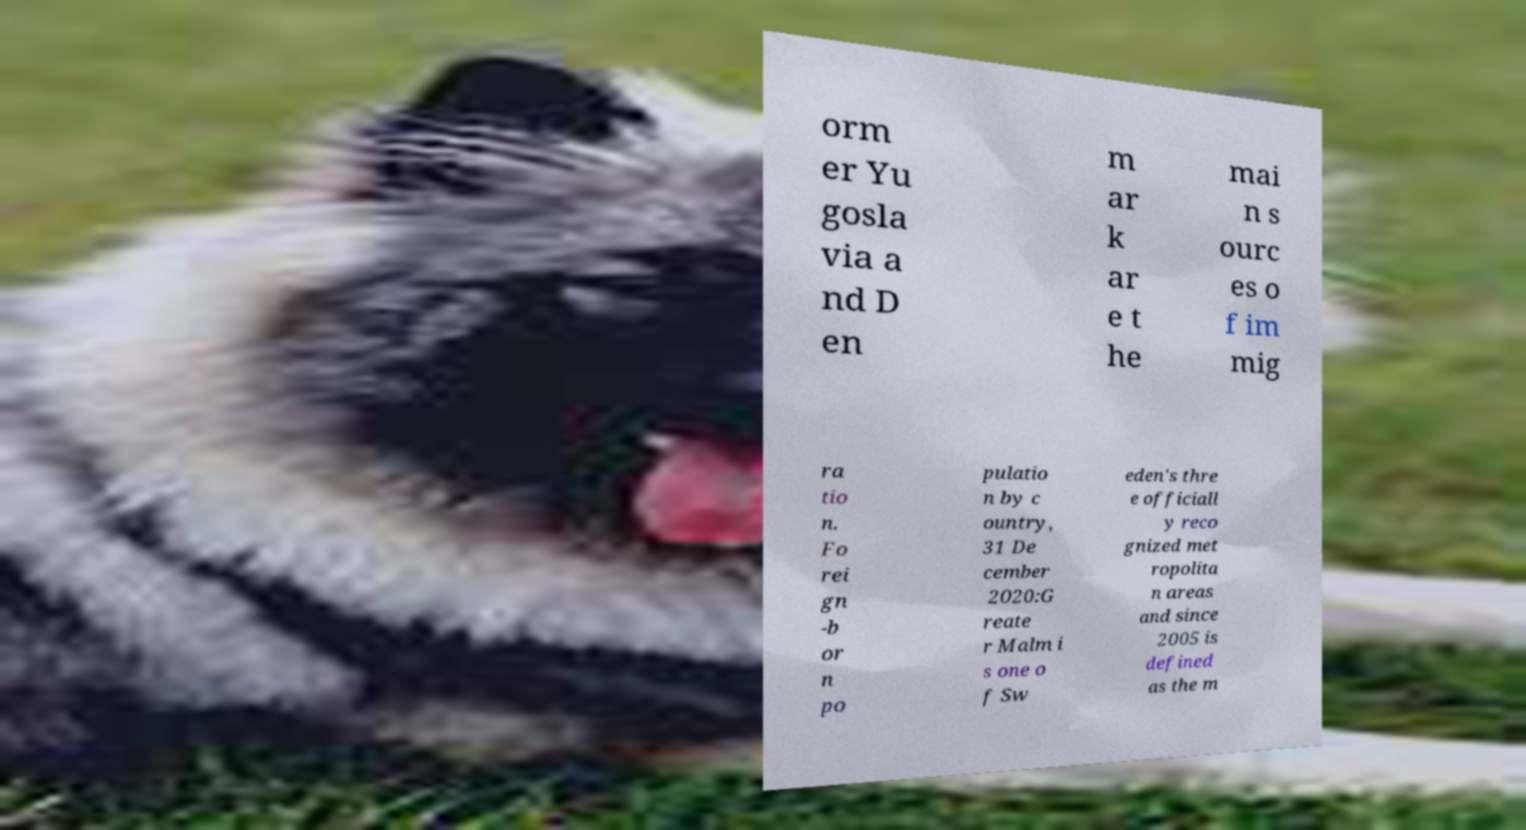Please read and relay the text visible in this image. What does it say? orm er Yu gosla via a nd D en m ar k ar e t he mai n s ourc es o f im mig ra tio n. Fo rei gn -b or n po pulatio n by c ountry, 31 De cember 2020:G reate r Malm i s one o f Sw eden's thre e officiall y reco gnized met ropolita n areas and since 2005 is defined as the m 